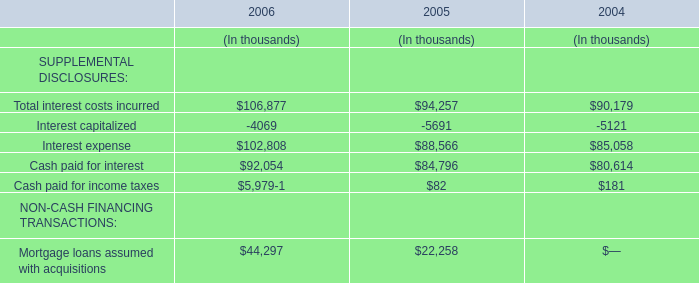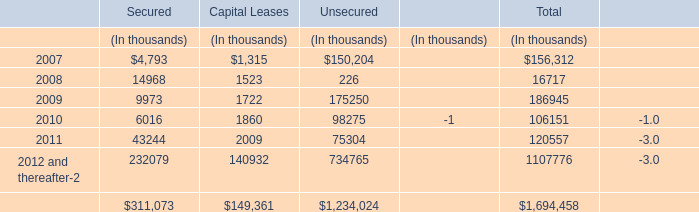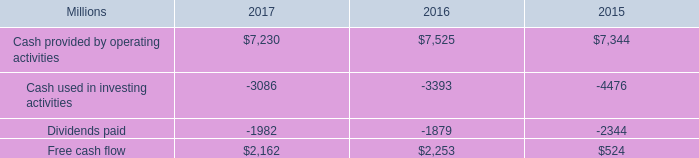what was the percent of the cash generated by operating activities in 2017 that was used for investing activities 
Computations: (3.1 / 7.2)
Answer: 0.43056. 